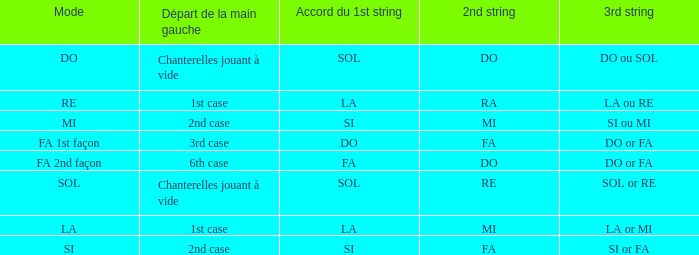What is the Depart de la main gauche of the do Mode? Chanterelles jouant à vide. 